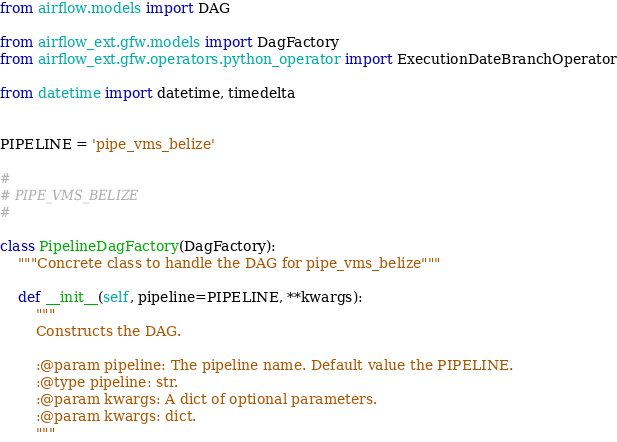Convert code to text. <code><loc_0><loc_0><loc_500><loc_500><_Python_>from airflow.models import DAG

from airflow_ext.gfw.models import DagFactory
from airflow_ext.gfw.operators.python_operator import ExecutionDateBranchOperator

from datetime import datetime, timedelta


PIPELINE = 'pipe_vms_belize'

#
# PIPE_VMS_BELIZE
#

class PipelineDagFactory(DagFactory):
    """Concrete class to handle the DAG for pipe_vms_belize"""

    def __init__(self, pipeline=PIPELINE, **kwargs):
        """
        Constructs the DAG.

        :@param pipeline: The pipeline name. Default value the PIPELINE.
        :@type pipeline: str.
        :@param kwargs: A dict of optional parameters.
        :@param kwargs: dict.
        """</code> 